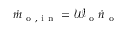Convert formula to latex. <formula><loc_0><loc_0><loc_500><loc_500>\dot { m } _ { o , i n } = \mathcal { W } _ { o } \dot { n } _ { o }</formula> 